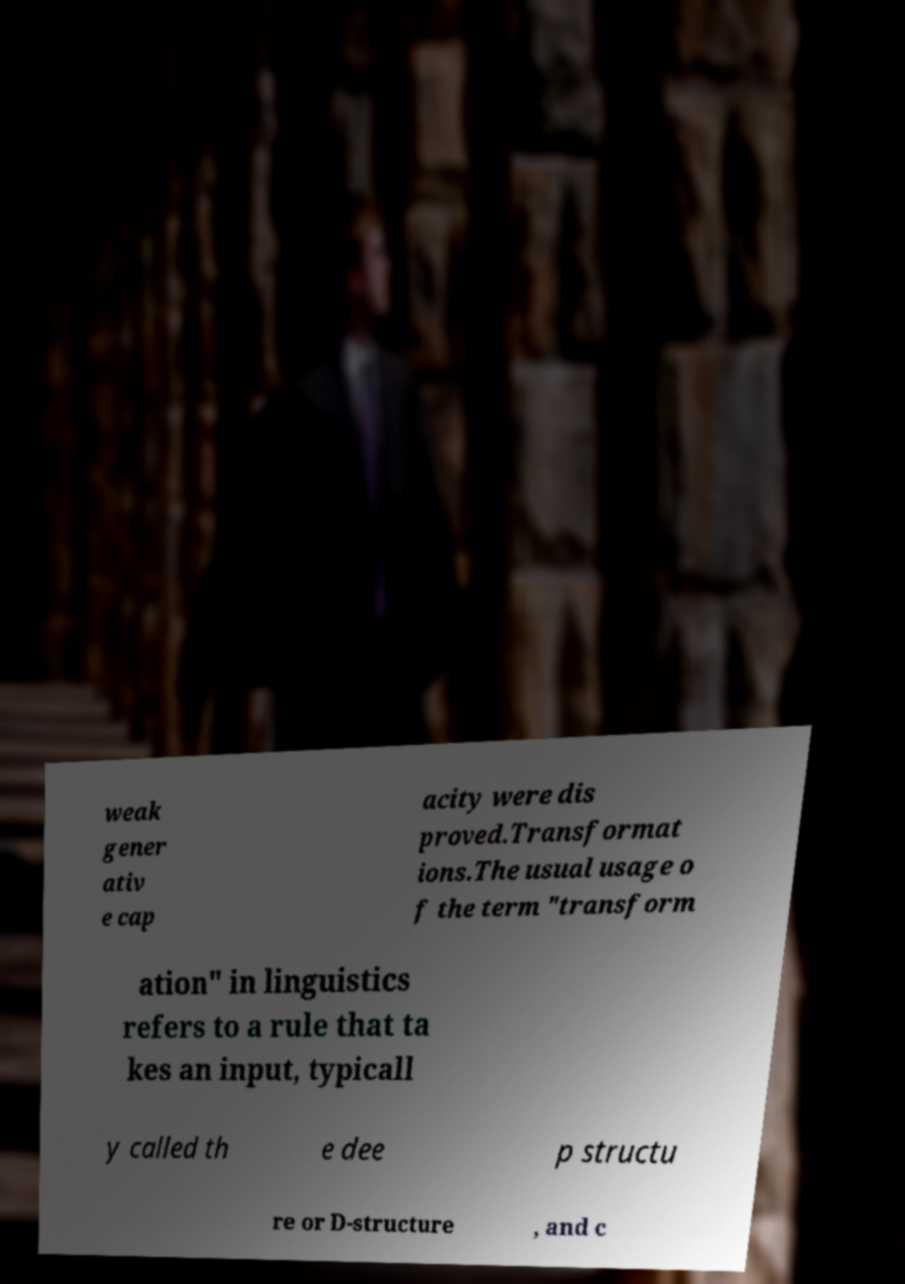Please read and relay the text visible in this image. What does it say? weak gener ativ e cap acity were dis proved.Transformat ions.The usual usage o f the term "transform ation" in linguistics refers to a rule that ta kes an input, typicall y called th e dee p structu re or D-structure , and c 